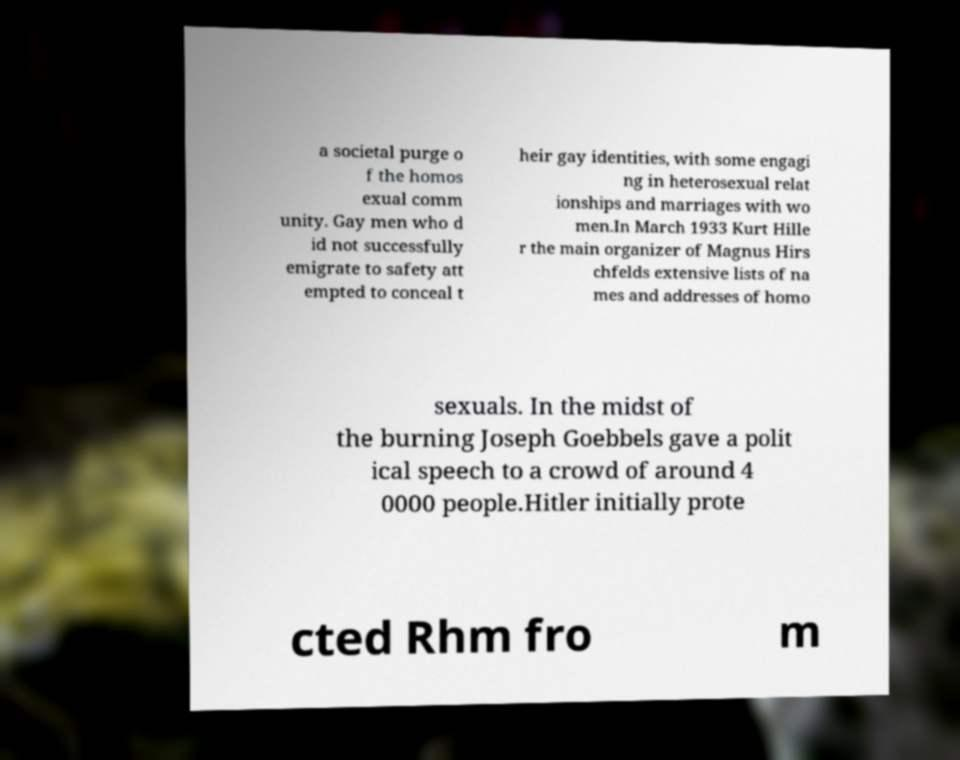Can you read and provide the text displayed in the image?This photo seems to have some interesting text. Can you extract and type it out for me? a societal purge o f the homos exual comm unity. Gay men who d id not successfully emigrate to safety att empted to conceal t heir gay identities, with some engagi ng in heterosexual relat ionships and marriages with wo men.In March 1933 Kurt Hille r the main organizer of Magnus Hirs chfelds extensive lists of na mes and addresses of homo sexuals. In the midst of the burning Joseph Goebbels gave a polit ical speech to a crowd of around 4 0000 people.Hitler initially prote cted Rhm fro m 